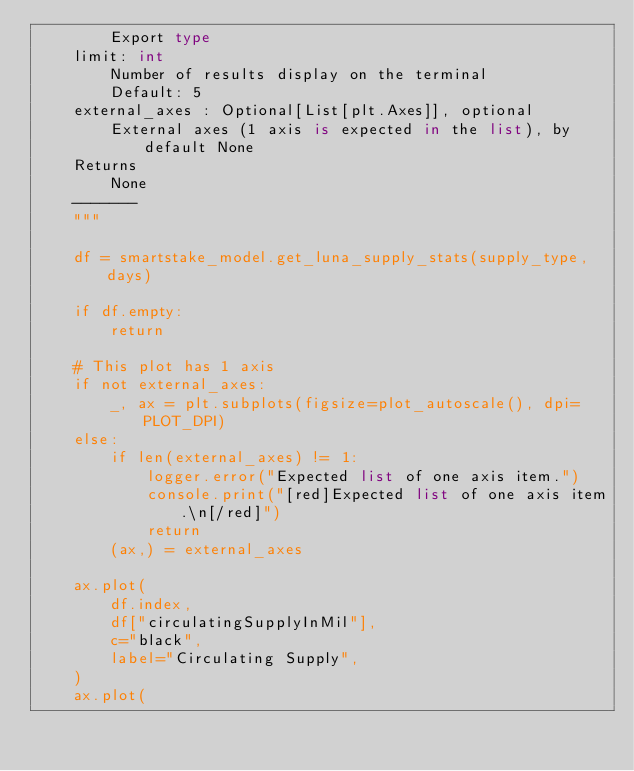Convert code to text. <code><loc_0><loc_0><loc_500><loc_500><_Python_>        Export type
    limit: int
        Number of results display on the terminal
        Default: 5
    external_axes : Optional[List[plt.Axes]], optional
        External axes (1 axis is expected in the list), by default None
    Returns
        None
    -------
    """

    df = smartstake_model.get_luna_supply_stats(supply_type, days)

    if df.empty:
        return

    # This plot has 1 axis
    if not external_axes:
        _, ax = plt.subplots(figsize=plot_autoscale(), dpi=PLOT_DPI)
    else:
        if len(external_axes) != 1:
            logger.error("Expected list of one axis item.")
            console.print("[red]Expected list of one axis item.\n[/red]")
            return
        (ax,) = external_axes

    ax.plot(
        df.index,
        df["circulatingSupplyInMil"],
        c="black",
        label="Circulating Supply",
    )
    ax.plot(</code> 